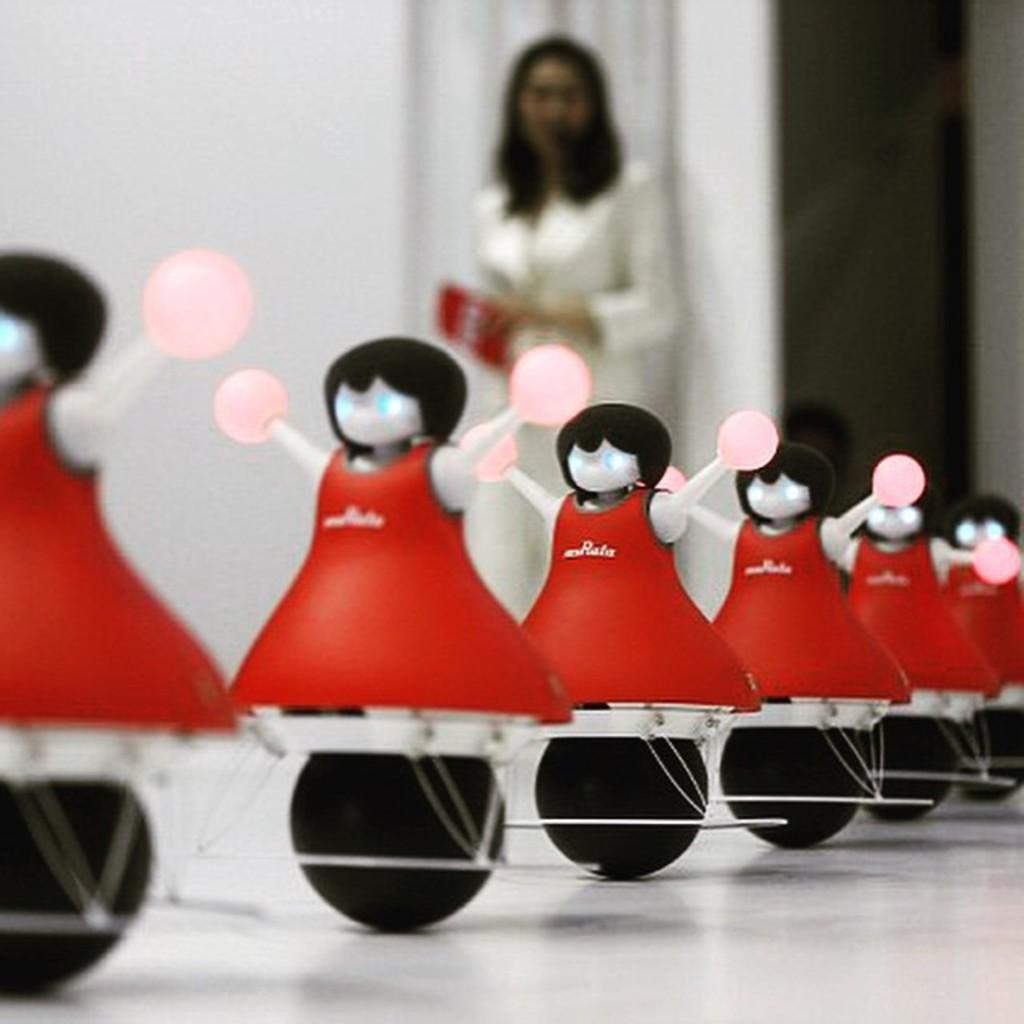What objects can be seen in the foreground of the image? There are toys in the foreground of the image. What is the color of the surface on which the toys are placed? The toys are on a white surface. What can be seen in the background of the image? There is a woman in the background of the image, and there is a wall in the background as well. What is the woman doing in the image? The woman is standing and holding an object. What type of light can be seen emanating from the toys in the image? There is no light emanating from the toys in the image; they are simply toys on a white surface. Can you tell me what kind of beast is present in the image? There is no beast present in the image; it features toys, a woman, and a wall. 